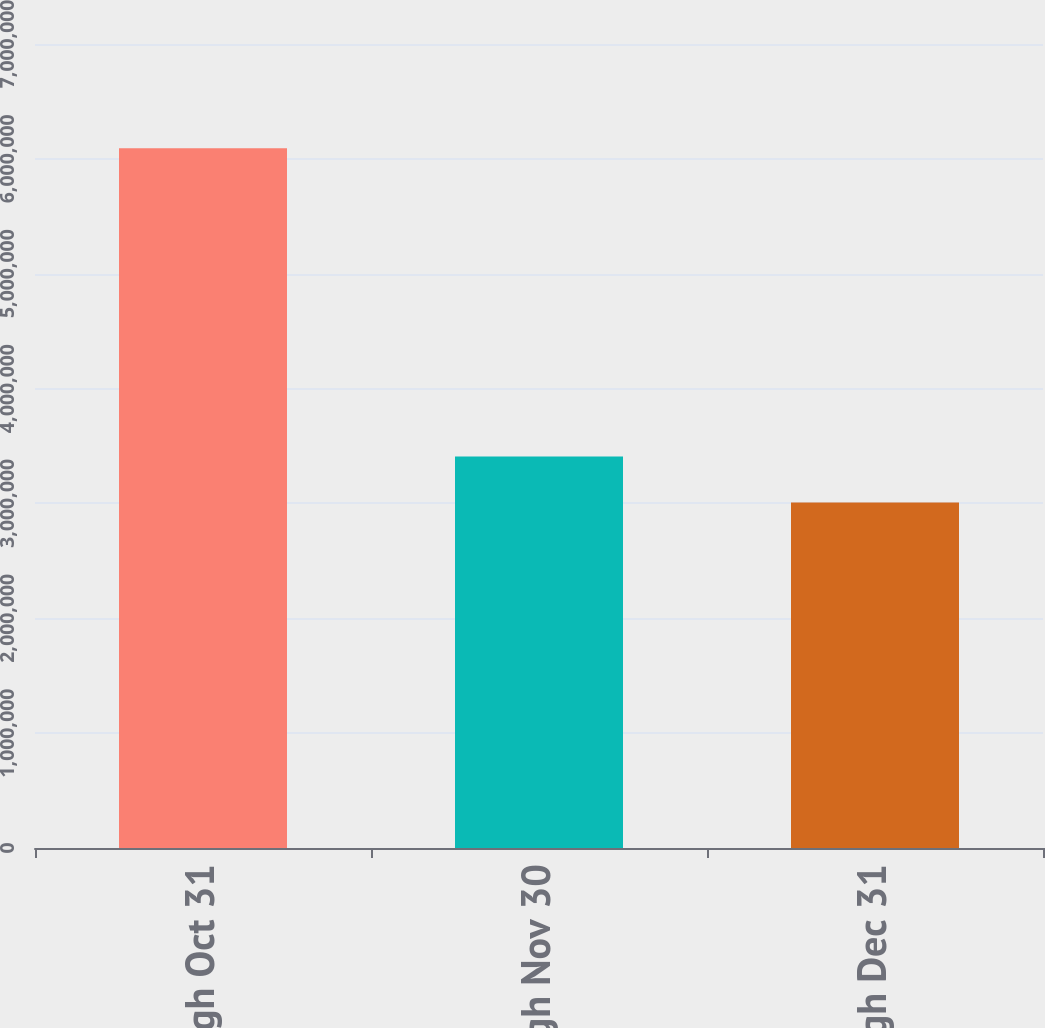Convert chart to OTSL. <chart><loc_0><loc_0><loc_500><loc_500><bar_chart><fcel>Oct 1 through Oct 31<fcel>Nov 1 through Nov 30<fcel>Dec 1 through Dec 31<nl><fcel>6.0916e+06<fcel>3.40847e+06<fcel>3.00795e+06<nl></chart> 